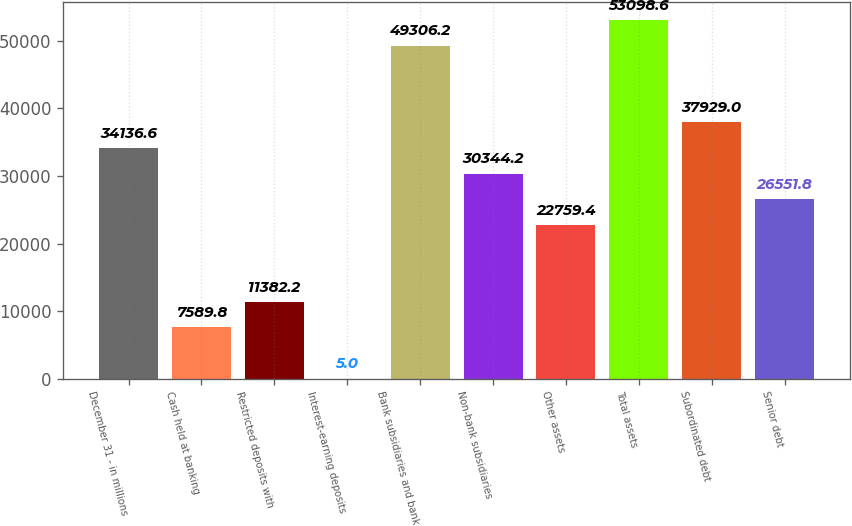Convert chart. <chart><loc_0><loc_0><loc_500><loc_500><bar_chart><fcel>December 31 - in millions<fcel>Cash held at banking<fcel>Restricted deposits with<fcel>Interest-earning deposits<fcel>Bank subsidiaries and bank<fcel>Non-bank subsidiaries<fcel>Other assets<fcel>Total assets<fcel>Subordinated debt<fcel>Senior debt<nl><fcel>34136.6<fcel>7589.8<fcel>11382.2<fcel>5<fcel>49306.2<fcel>30344.2<fcel>22759.4<fcel>53098.6<fcel>37929<fcel>26551.8<nl></chart> 